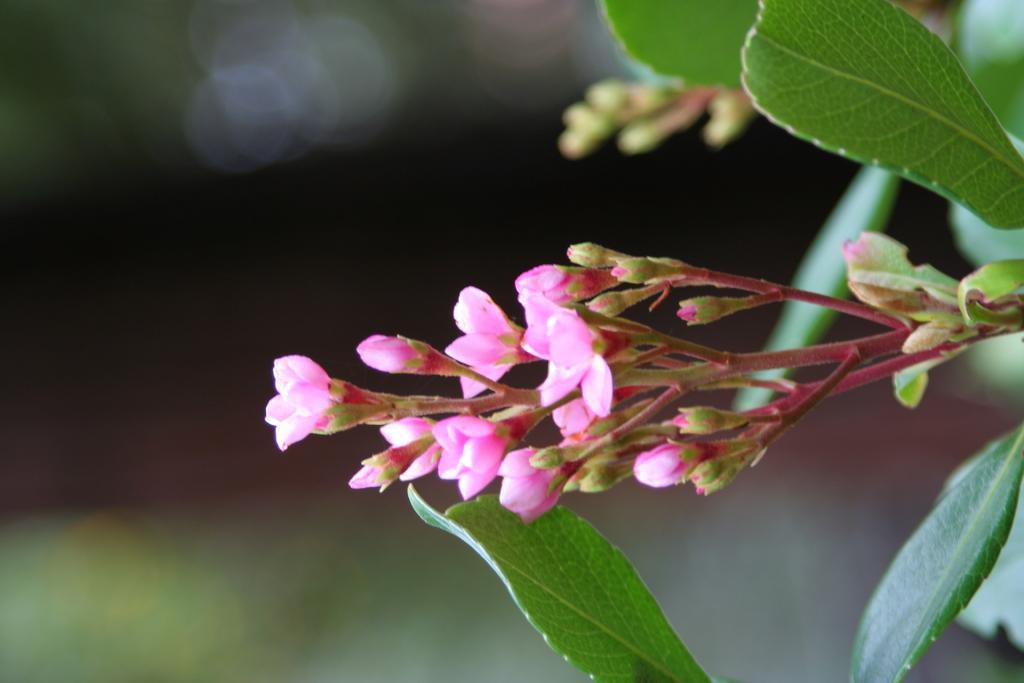How would you summarize this image in a sentence or two? This is a zoomed in picture. On the right we can see the flowers and the buds and we can see the leaves of a plant. The background of the image is very blurry. 